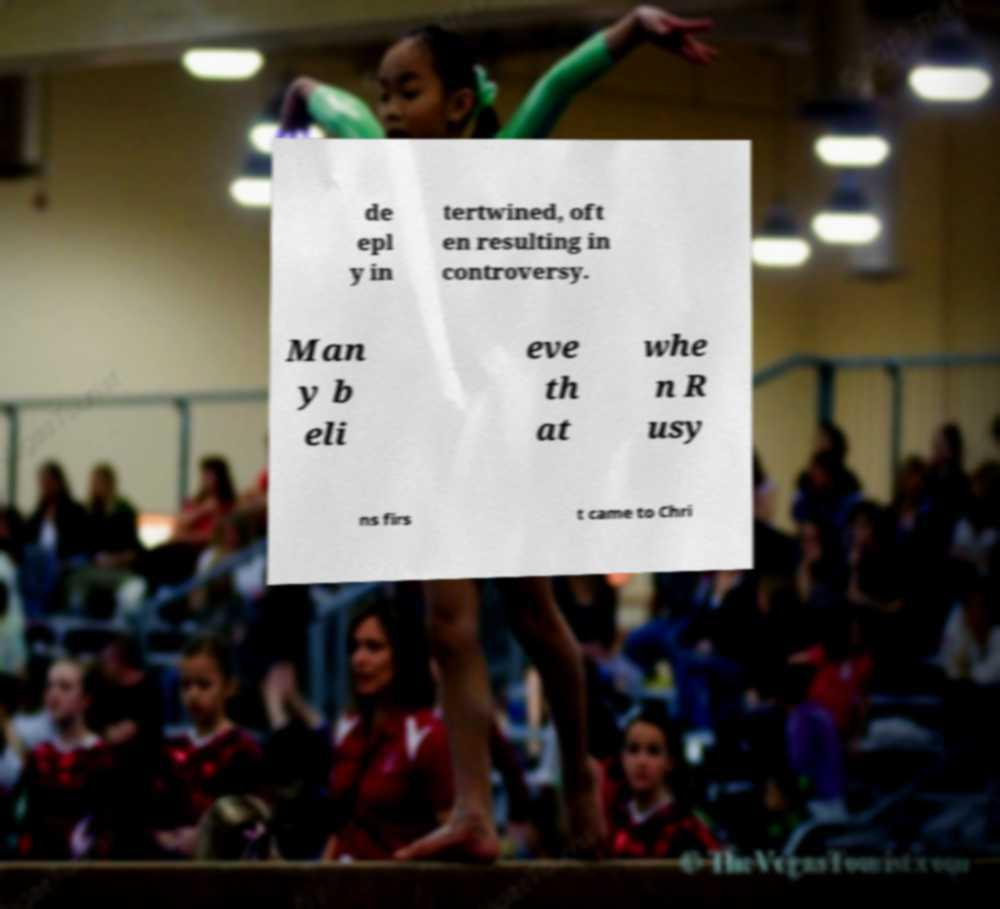Could you extract and type out the text from this image? de epl y in tertwined, oft en resulting in controversy. Man y b eli eve th at whe n R usy ns firs t came to Chri 